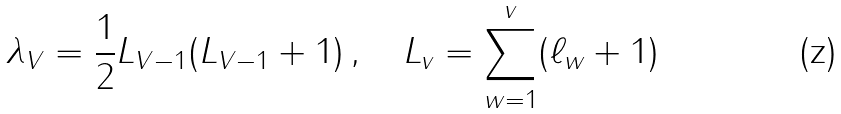<formula> <loc_0><loc_0><loc_500><loc_500>\lambda _ { V } = \frac { 1 } { 2 } L _ { V - 1 } ( L _ { V - 1 } + 1 ) \, , \quad L _ { v } = \sum _ { w = 1 } ^ { v } ( \ell _ { w } + 1 )</formula> 